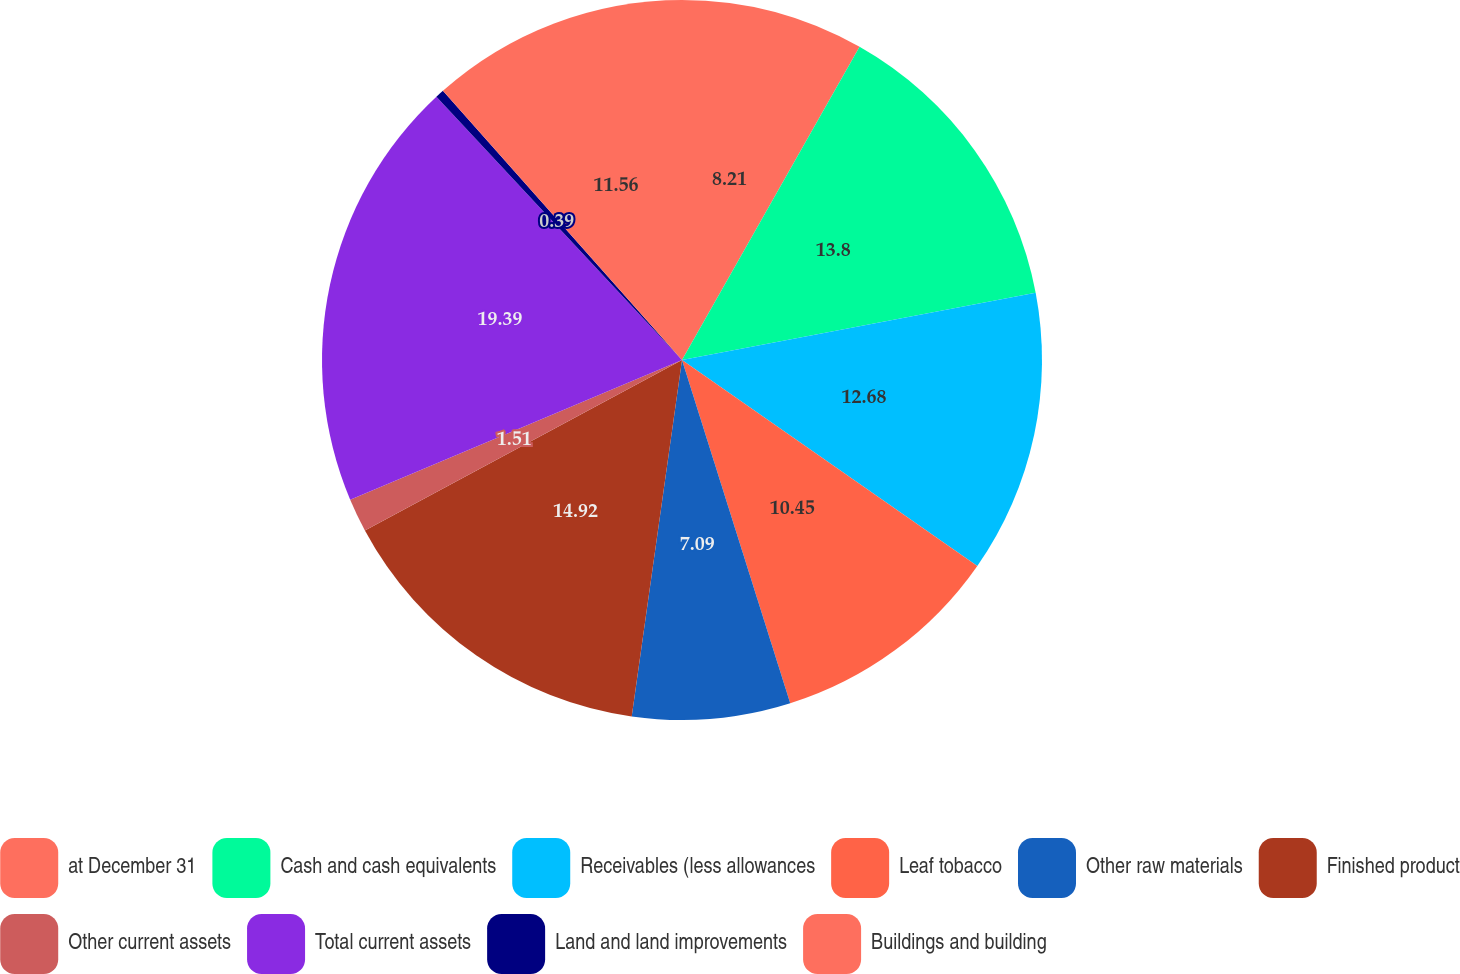Convert chart to OTSL. <chart><loc_0><loc_0><loc_500><loc_500><pie_chart><fcel>at December 31<fcel>Cash and cash equivalents<fcel>Receivables (less allowances<fcel>Leaf tobacco<fcel>Other raw materials<fcel>Finished product<fcel>Other current assets<fcel>Total current assets<fcel>Land and land improvements<fcel>Buildings and building<nl><fcel>8.21%<fcel>13.8%<fcel>12.68%<fcel>10.45%<fcel>7.09%<fcel>14.92%<fcel>1.51%<fcel>19.39%<fcel>0.39%<fcel>11.56%<nl></chart> 